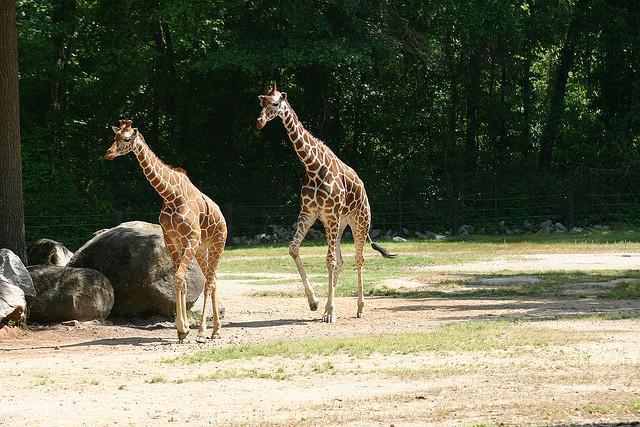How many animals can be seen?
Give a very brief answer. 2. How many giraffes are there?
Give a very brief answer. 2. How many giraffes are in the photo?
Give a very brief answer. 2. 